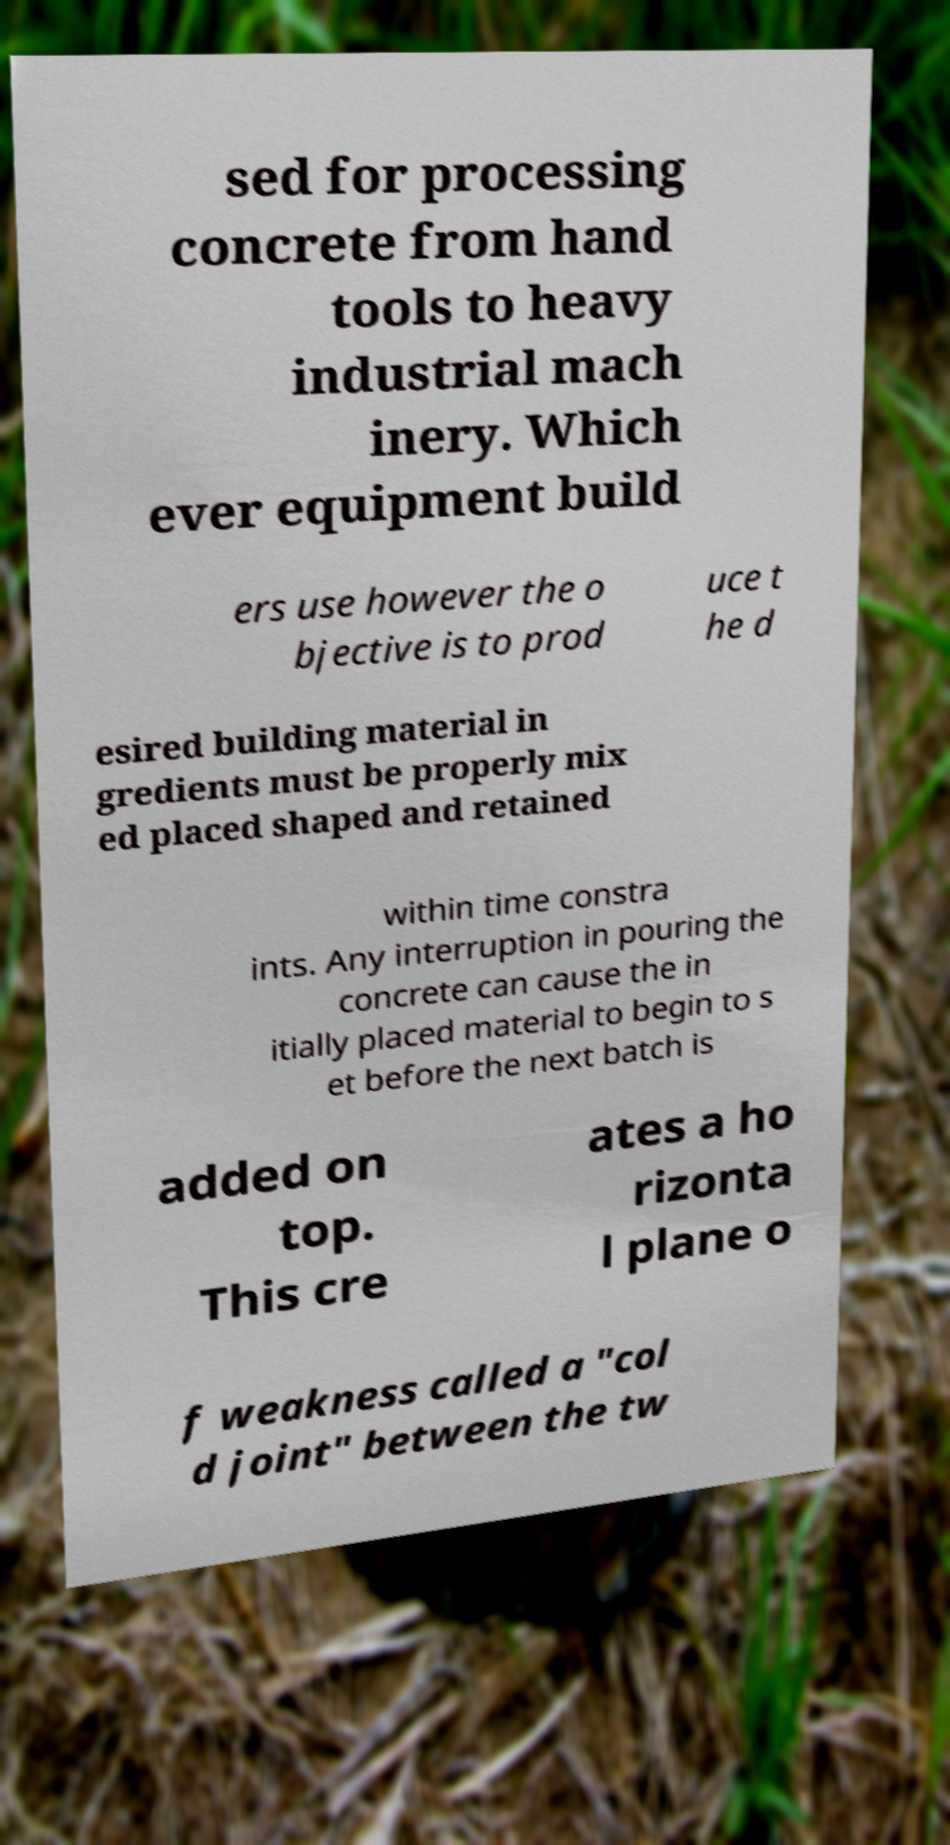For documentation purposes, I need the text within this image transcribed. Could you provide that? sed for processing concrete from hand tools to heavy industrial mach inery. Which ever equipment build ers use however the o bjective is to prod uce t he d esired building material in gredients must be properly mix ed placed shaped and retained within time constra ints. Any interruption in pouring the concrete can cause the in itially placed material to begin to s et before the next batch is added on top. This cre ates a ho rizonta l plane o f weakness called a "col d joint" between the tw 